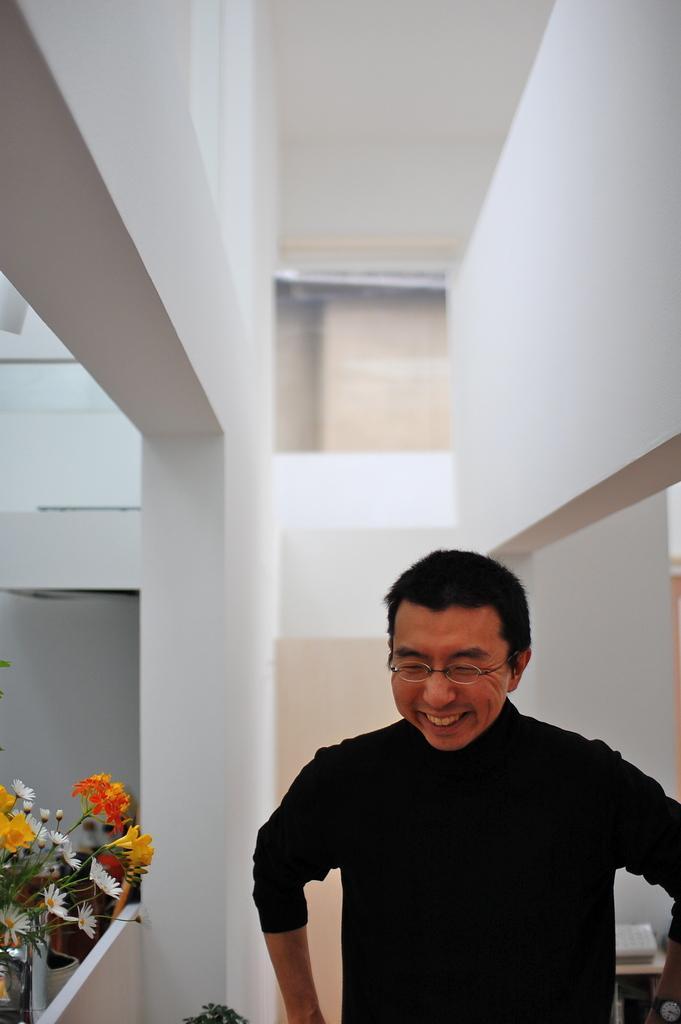Could you give a brief overview of what you see in this image? A man is standing, there is a plant, this is wall. 